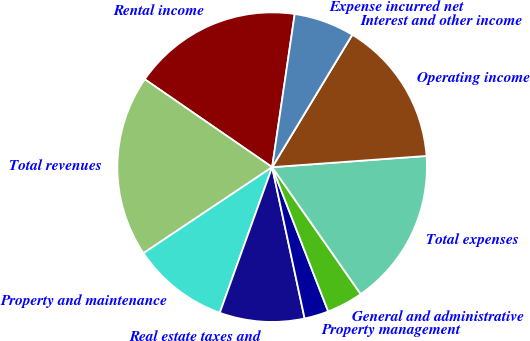<chart> <loc_0><loc_0><loc_500><loc_500><pie_chart><fcel>Rental income<fcel>Total revenues<fcel>Property and maintenance<fcel>Real estate taxes and<fcel>Property management<fcel>General and administrative<fcel>Total expenses<fcel>Operating income<fcel>Interest and other income<fcel>Expense incurred net<nl><fcel>17.72%<fcel>18.99%<fcel>10.13%<fcel>8.86%<fcel>2.53%<fcel>3.8%<fcel>16.46%<fcel>15.19%<fcel>0.0%<fcel>6.33%<nl></chart> 